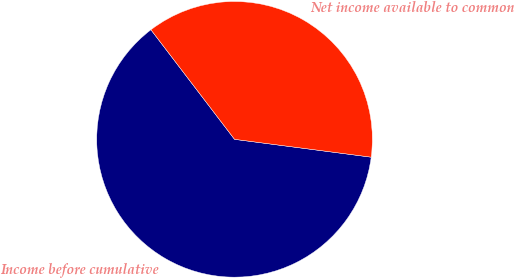<chart> <loc_0><loc_0><loc_500><loc_500><pie_chart><fcel>Income before cumulative<fcel>Net income available to common<nl><fcel>62.56%<fcel>37.44%<nl></chart> 